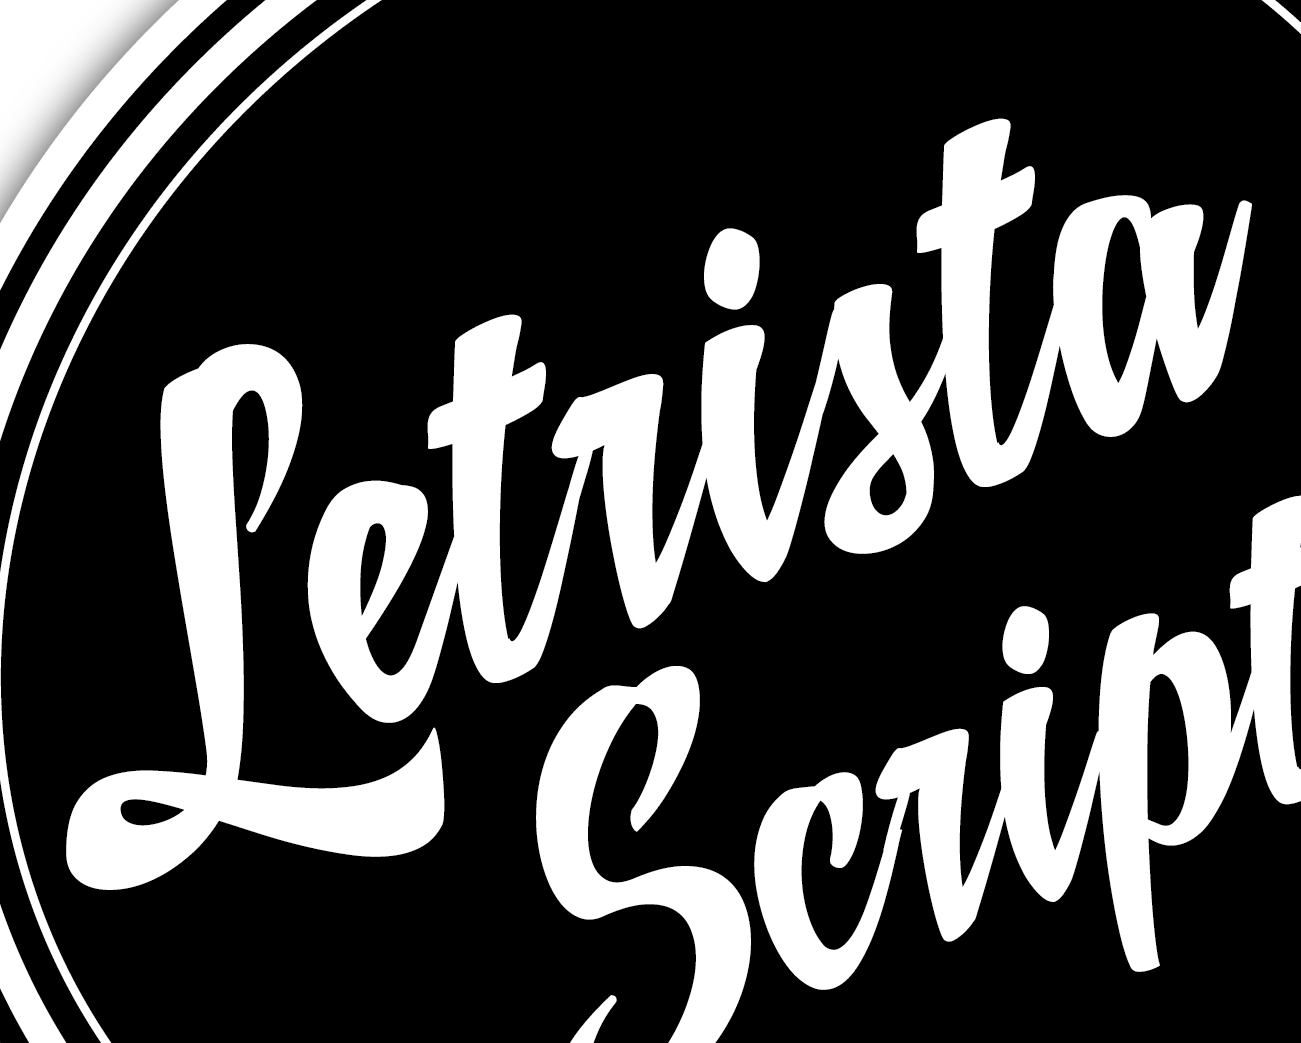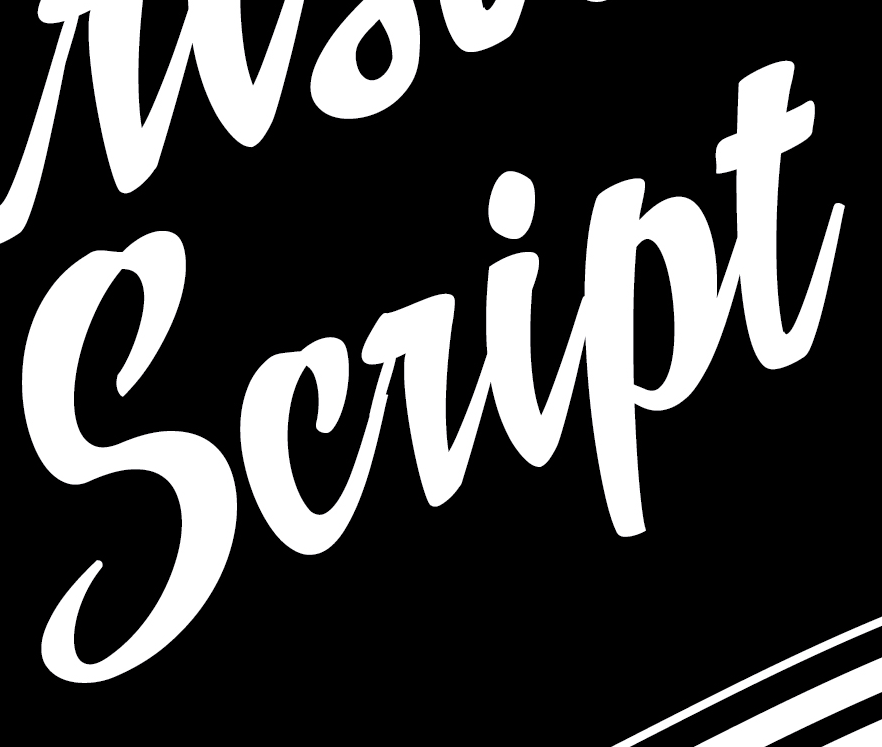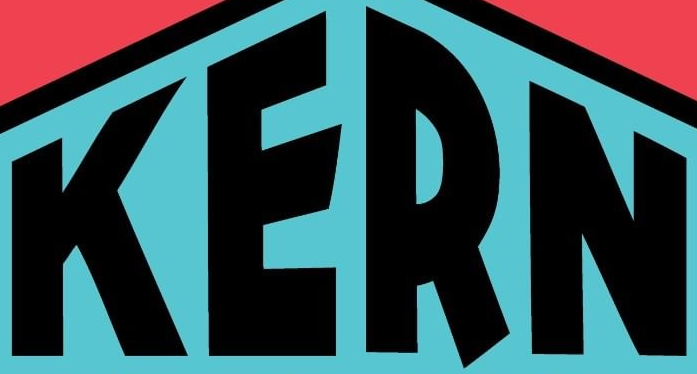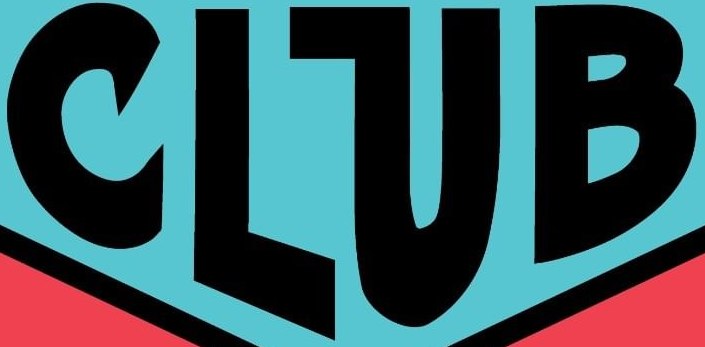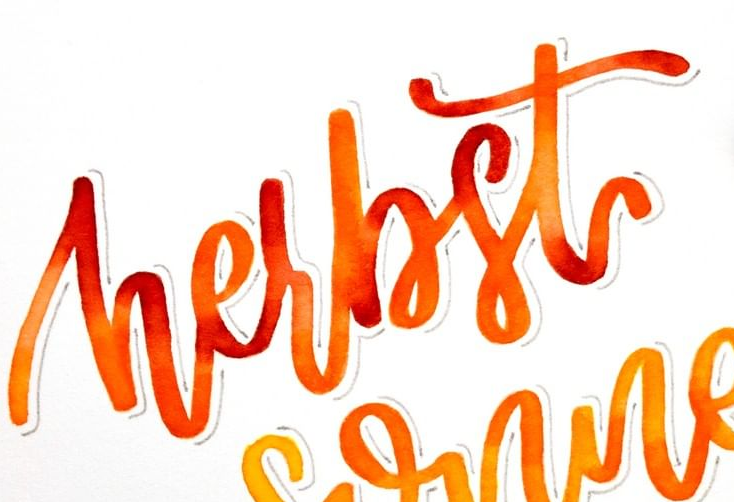Transcribe the words shown in these images in order, separated by a semicolon. Letrista; script; KERN; CLUB; hesbst 